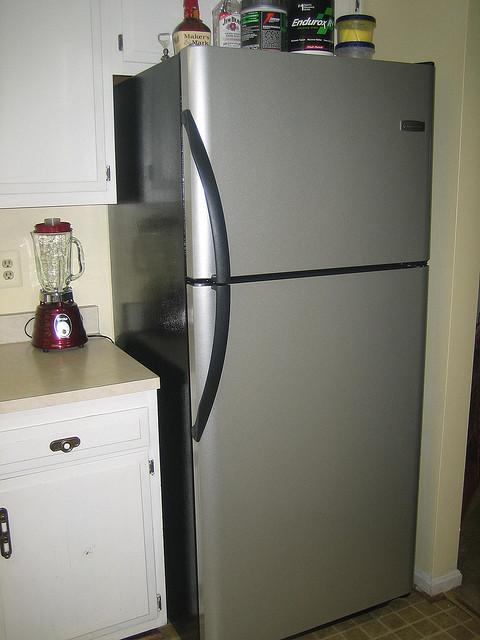Extract all visible text content from this image. Endurox 